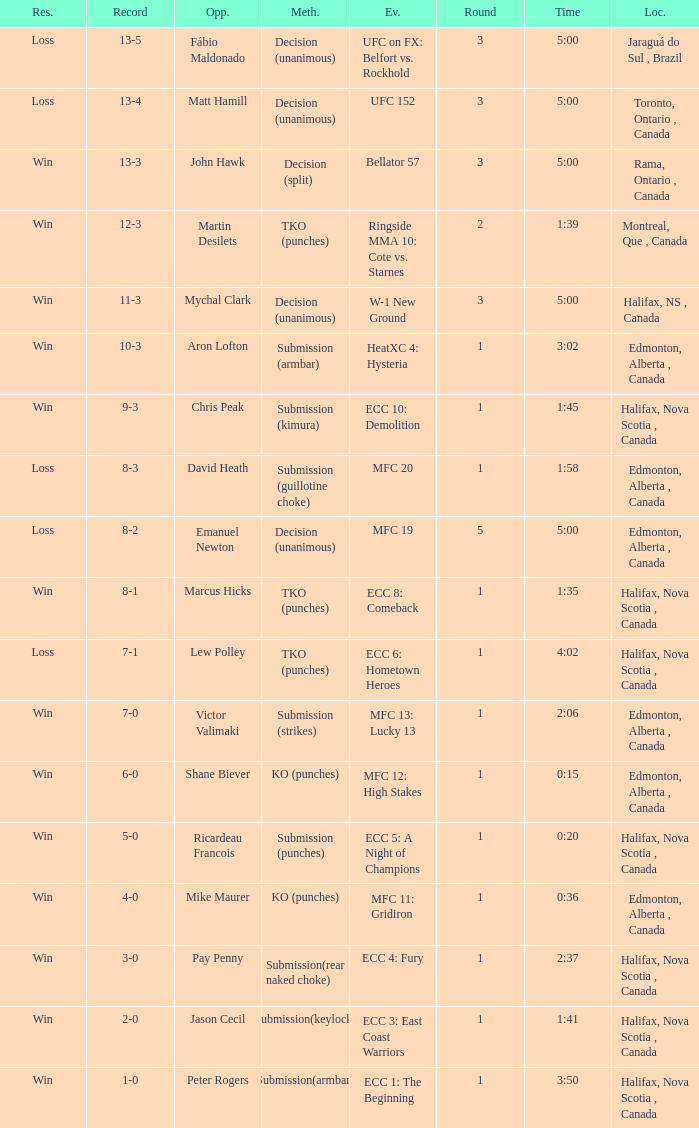Who is the opponent of the match with a win result and a time of 3:02? Aron Lofton. 